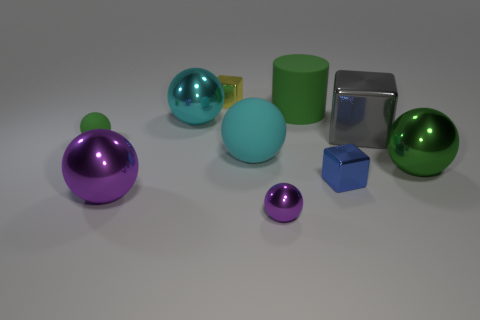Subtract all blue blocks. How many blocks are left? 2 Subtract all big green balls. How many balls are left? 5 Subtract all yellow cubes. Subtract all blue spheres. How many cubes are left? 2 Add 3 gray metal cubes. How many gray metal cubes exist? 4 Subtract 1 purple spheres. How many objects are left? 9 Subtract all blocks. How many objects are left? 7 Subtract 1 cylinders. How many cylinders are left? 0 Subtract all red spheres. How many yellow cubes are left? 1 Subtract all big gray things. Subtract all big purple spheres. How many objects are left? 8 Add 6 rubber things. How many rubber things are left? 9 